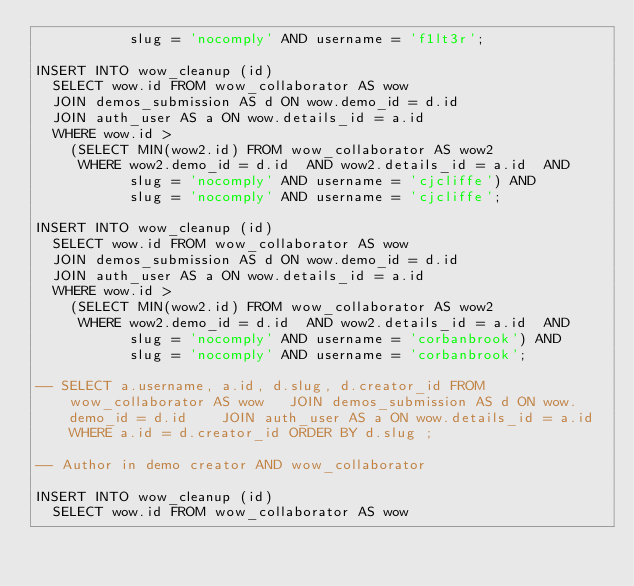Convert code to text. <code><loc_0><loc_0><loc_500><loc_500><_SQL_>           slug = 'nocomply' AND username = 'f1lt3r';

INSERT INTO wow_cleanup (id)
  SELECT wow.id FROM wow_collaborator AS wow
  JOIN demos_submission AS d ON wow.demo_id = d.id 
  JOIN auth_user AS a ON wow.details_id = a.id 
  WHERE wow.id > 
    (SELECT MIN(wow2.id) FROM wow_collaborator AS wow2
     WHERE wow2.demo_id = d.id  AND wow2.details_id = a.id  AND
           slug = 'nocomply' AND username = 'cjcliffe') AND 
           slug = 'nocomply' AND username = 'cjcliffe';

INSERT INTO wow_cleanup (id)
  SELECT wow.id FROM wow_collaborator AS wow
  JOIN demos_submission AS d ON wow.demo_id = d.id 
  JOIN auth_user AS a ON wow.details_id = a.id 
  WHERE wow.id > 
    (SELECT MIN(wow2.id) FROM wow_collaborator AS wow2
     WHERE wow2.demo_id = d.id  AND wow2.details_id = a.id  AND
           slug = 'nocomply' AND username = 'corbanbrook') AND 
           slug = 'nocomply' AND username = 'corbanbrook';

-- SELECT a.username, a.id, d.slug, d.creator_id FROM wow_collaborator AS wow   JOIN demos_submission AS d ON wow.demo_id = d.id    JOIN auth_user AS a ON wow.details_id = a.id WHERE a.id = d.creator_id ORDER BY d.slug ;

-- Author in demo creator AND wow_collaborator

INSERT INTO wow_cleanup (id)
  SELECT wow.id FROM wow_collaborator AS wow</code> 